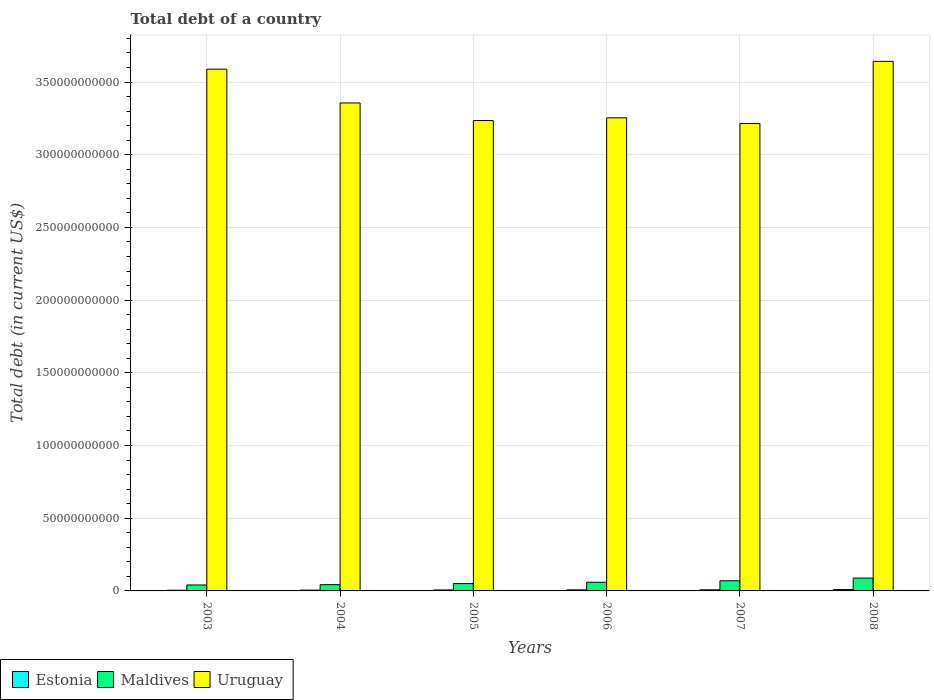Are the number of bars per tick equal to the number of legend labels?
Provide a succinct answer. Yes. What is the debt in Uruguay in 2003?
Give a very brief answer. 3.59e+11. Across all years, what is the maximum debt in Estonia?
Offer a very short reply. 9.20e+08. Across all years, what is the minimum debt in Uruguay?
Provide a short and direct response. 3.22e+11. In which year was the debt in Estonia maximum?
Your answer should be compact. 2008. What is the total debt in Uruguay in the graph?
Ensure brevity in your answer.  2.03e+12. What is the difference between the debt in Maldives in 2003 and that in 2004?
Offer a very short reply. -1.95e+08. What is the difference between the debt in Uruguay in 2003 and the debt in Maldives in 2004?
Ensure brevity in your answer.  3.55e+11. What is the average debt in Maldives per year?
Provide a succinct answer. 5.86e+09. In the year 2003, what is the difference between the debt in Uruguay and debt in Maldives?
Offer a very short reply. 3.55e+11. What is the ratio of the debt in Uruguay in 2004 to that in 2006?
Ensure brevity in your answer.  1.03. What is the difference between the highest and the second highest debt in Maldives?
Keep it short and to the point. 1.84e+09. What is the difference between the highest and the lowest debt in Uruguay?
Provide a short and direct response. 4.27e+1. In how many years, is the debt in Uruguay greater than the average debt in Uruguay taken over all years?
Make the answer very short. 2. What does the 1st bar from the left in 2008 represents?
Offer a terse response. Estonia. What does the 2nd bar from the right in 2003 represents?
Offer a very short reply. Maldives. Is it the case that in every year, the sum of the debt in Estonia and debt in Maldives is greater than the debt in Uruguay?
Ensure brevity in your answer.  No. How many bars are there?
Your answer should be compact. 18. How many years are there in the graph?
Provide a succinct answer. 6. Are the values on the major ticks of Y-axis written in scientific E-notation?
Ensure brevity in your answer.  No. Does the graph contain grids?
Provide a short and direct response. Yes. Where does the legend appear in the graph?
Your response must be concise. Bottom left. How many legend labels are there?
Your response must be concise. 3. How are the legend labels stacked?
Provide a succinct answer. Horizontal. What is the title of the graph?
Keep it short and to the point. Total debt of a country. What is the label or title of the X-axis?
Keep it short and to the point. Years. What is the label or title of the Y-axis?
Ensure brevity in your answer.  Total debt (in current US$). What is the Total debt (in current US$) in Estonia in 2003?
Make the answer very short. 4.56e+08. What is the Total debt (in current US$) in Maldives in 2003?
Keep it short and to the point. 4.09e+09. What is the Total debt (in current US$) in Uruguay in 2003?
Your answer should be compact. 3.59e+11. What is the Total debt (in current US$) in Estonia in 2004?
Give a very brief answer. 5.30e+08. What is the Total debt (in current US$) of Maldives in 2004?
Provide a succinct answer. 4.28e+09. What is the Total debt (in current US$) in Uruguay in 2004?
Provide a succinct answer. 3.36e+11. What is the Total debt (in current US$) in Estonia in 2005?
Your answer should be compact. 6.56e+08. What is the Total debt (in current US$) in Maldives in 2005?
Offer a terse response. 5.05e+09. What is the Total debt (in current US$) in Uruguay in 2005?
Keep it short and to the point. 3.24e+11. What is the Total debt (in current US$) in Estonia in 2006?
Your response must be concise. 7.41e+08. What is the Total debt (in current US$) in Maldives in 2006?
Give a very brief answer. 5.96e+09. What is the Total debt (in current US$) in Uruguay in 2006?
Your response must be concise. 3.25e+11. What is the Total debt (in current US$) in Estonia in 2007?
Provide a succinct answer. 7.73e+08. What is the Total debt (in current US$) of Maldives in 2007?
Your answer should be compact. 6.98e+09. What is the Total debt (in current US$) of Uruguay in 2007?
Your answer should be very brief. 3.22e+11. What is the Total debt (in current US$) in Estonia in 2008?
Offer a terse response. 9.20e+08. What is the Total debt (in current US$) of Maldives in 2008?
Keep it short and to the point. 8.82e+09. What is the Total debt (in current US$) in Uruguay in 2008?
Offer a terse response. 3.64e+11. Across all years, what is the maximum Total debt (in current US$) in Estonia?
Offer a very short reply. 9.20e+08. Across all years, what is the maximum Total debt (in current US$) in Maldives?
Provide a succinct answer. 8.82e+09. Across all years, what is the maximum Total debt (in current US$) of Uruguay?
Provide a succinct answer. 3.64e+11. Across all years, what is the minimum Total debt (in current US$) in Estonia?
Provide a short and direct response. 4.56e+08. Across all years, what is the minimum Total debt (in current US$) in Maldives?
Make the answer very short. 4.09e+09. Across all years, what is the minimum Total debt (in current US$) of Uruguay?
Offer a terse response. 3.22e+11. What is the total Total debt (in current US$) in Estonia in the graph?
Offer a terse response. 4.08e+09. What is the total Total debt (in current US$) of Maldives in the graph?
Offer a very short reply. 3.52e+1. What is the total Total debt (in current US$) in Uruguay in the graph?
Provide a succinct answer. 2.03e+12. What is the difference between the Total debt (in current US$) in Estonia in 2003 and that in 2004?
Offer a very short reply. -7.38e+07. What is the difference between the Total debt (in current US$) of Maldives in 2003 and that in 2004?
Your answer should be compact. -1.95e+08. What is the difference between the Total debt (in current US$) of Uruguay in 2003 and that in 2004?
Provide a succinct answer. 2.32e+1. What is the difference between the Total debt (in current US$) in Estonia in 2003 and that in 2005?
Offer a terse response. -1.99e+08. What is the difference between the Total debt (in current US$) in Maldives in 2003 and that in 2005?
Offer a very short reply. -9.64e+08. What is the difference between the Total debt (in current US$) in Uruguay in 2003 and that in 2005?
Provide a short and direct response. 3.53e+1. What is the difference between the Total debt (in current US$) in Estonia in 2003 and that in 2006?
Your answer should be very brief. -2.85e+08. What is the difference between the Total debt (in current US$) of Maldives in 2003 and that in 2006?
Make the answer very short. -1.87e+09. What is the difference between the Total debt (in current US$) of Uruguay in 2003 and that in 2006?
Give a very brief answer. 3.35e+1. What is the difference between the Total debt (in current US$) of Estonia in 2003 and that in 2007?
Make the answer very short. -3.17e+08. What is the difference between the Total debt (in current US$) in Maldives in 2003 and that in 2007?
Your answer should be very brief. -2.89e+09. What is the difference between the Total debt (in current US$) of Uruguay in 2003 and that in 2007?
Your answer should be compact. 3.73e+1. What is the difference between the Total debt (in current US$) of Estonia in 2003 and that in 2008?
Provide a succinct answer. -4.64e+08. What is the difference between the Total debt (in current US$) in Maldives in 2003 and that in 2008?
Make the answer very short. -4.74e+09. What is the difference between the Total debt (in current US$) in Uruguay in 2003 and that in 2008?
Give a very brief answer. -5.38e+09. What is the difference between the Total debt (in current US$) of Estonia in 2004 and that in 2005?
Keep it short and to the point. -1.26e+08. What is the difference between the Total debt (in current US$) of Maldives in 2004 and that in 2005?
Offer a very short reply. -7.69e+08. What is the difference between the Total debt (in current US$) of Uruguay in 2004 and that in 2005?
Your response must be concise. 1.21e+1. What is the difference between the Total debt (in current US$) in Estonia in 2004 and that in 2006?
Provide a succinct answer. -2.11e+08. What is the difference between the Total debt (in current US$) in Maldives in 2004 and that in 2006?
Your response must be concise. -1.67e+09. What is the difference between the Total debt (in current US$) of Uruguay in 2004 and that in 2006?
Your response must be concise. 1.02e+1. What is the difference between the Total debt (in current US$) in Estonia in 2004 and that in 2007?
Provide a succinct answer. -2.43e+08. What is the difference between the Total debt (in current US$) of Maldives in 2004 and that in 2007?
Provide a succinct answer. -2.70e+09. What is the difference between the Total debt (in current US$) of Uruguay in 2004 and that in 2007?
Keep it short and to the point. 1.41e+1. What is the difference between the Total debt (in current US$) in Estonia in 2004 and that in 2008?
Your response must be concise. -3.90e+08. What is the difference between the Total debt (in current US$) in Maldives in 2004 and that in 2008?
Provide a short and direct response. -4.54e+09. What is the difference between the Total debt (in current US$) in Uruguay in 2004 and that in 2008?
Make the answer very short. -2.86e+1. What is the difference between the Total debt (in current US$) in Estonia in 2005 and that in 2006?
Offer a terse response. -8.56e+07. What is the difference between the Total debt (in current US$) in Maldives in 2005 and that in 2006?
Make the answer very short. -9.04e+08. What is the difference between the Total debt (in current US$) of Uruguay in 2005 and that in 2006?
Provide a short and direct response. -1.85e+09. What is the difference between the Total debt (in current US$) of Estonia in 2005 and that in 2007?
Offer a terse response. -1.18e+08. What is the difference between the Total debt (in current US$) in Maldives in 2005 and that in 2007?
Keep it short and to the point. -1.93e+09. What is the difference between the Total debt (in current US$) in Uruguay in 2005 and that in 2007?
Provide a short and direct response. 1.99e+09. What is the difference between the Total debt (in current US$) of Estonia in 2005 and that in 2008?
Keep it short and to the point. -2.64e+08. What is the difference between the Total debt (in current US$) in Maldives in 2005 and that in 2008?
Your answer should be very brief. -3.77e+09. What is the difference between the Total debt (in current US$) of Uruguay in 2005 and that in 2008?
Offer a very short reply. -4.07e+1. What is the difference between the Total debt (in current US$) of Estonia in 2006 and that in 2007?
Keep it short and to the point. -3.21e+07. What is the difference between the Total debt (in current US$) in Maldives in 2006 and that in 2007?
Offer a terse response. -1.02e+09. What is the difference between the Total debt (in current US$) of Uruguay in 2006 and that in 2007?
Your response must be concise. 3.85e+09. What is the difference between the Total debt (in current US$) of Estonia in 2006 and that in 2008?
Provide a succinct answer. -1.79e+08. What is the difference between the Total debt (in current US$) of Maldives in 2006 and that in 2008?
Provide a succinct answer. -2.87e+09. What is the difference between the Total debt (in current US$) of Uruguay in 2006 and that in 2008?
Keep it short and to the point. -3.89e+1. What is the difference between the Total debt (in current US$) in Estonia in 2007 and that in 2008?
Offer a very short reply. -1.47e+08. What is the difference between the Total debt (in current US$) in Maldives in 2007 and that in 2008?
Ensure brevity in your answer.  -1.84e+09. What is the difference between the Total debt (in current US$) in Uruguay in 2007 and that in 2008?
Your answer should be very brief. -4.27e+1. What is the difference between the Total debt (in current US$) in Estonia in 2003 and the Total debt (in current US$) in Maldives in 2004?
Offer a terse response. -3.83e+09. What is the difference between the Total debt (in current US$) in Estonia in 2003 and the Total debt (in current US$) in Uruguay in 2004?
Keep it short and to the point. -3.35e+11. What is the difference between the Total debt (in current US$) in Maldives in 2003 and the Total debt (in current US$) in Uruguay in 2004?
Ensure brevity in your answer.  -3.32e+11. What is the difference between the Total debt (in current US$) in Estonia in 2003 and the Total debt (in current US$) in Maldives in 2005?
Your answer should be very brief. -4.60e+09. What is the difference between the Total debt (in current US$) in Estonia in 2003 and the Total debt (in current US$) in Uruguay in 2005?
Ensure brevity in your answer.  -3.23e+11. What is the difference between the Total debt (in current US$) of Maldives in 2003 and the Total debt (in current US$) of Uruguay in 2005?
Provide a succinct answer. -3.19e+11. What is the difference between the Total debt (in current US$) of Estonia in 2003 and the Total debt (in current US$) of Maldives in 2006?
Offer a very short reply. -5.50e+09. What is the difference between the Total debt (in current US$) in Estonia in 2003 and the Total debt (in current US$) in Uruguay in 2006?
Offer a terse response. -3.25e+11. What is the difference between the Total debt (in current US$) in Maldives in 2003 and the Total debt (in current US$) in Uruguay in 2006?
Provide a succinct answer. -3.21e+11. What is the difference between the Total debt (in current US$) in Estonia in 2003 and the Total debt (in current US$) in Maldives in 2007?
Ensure brevity in your answer.  -6.52e+09. What is the difference between the Total debt (in current US$) in Estonia in 2003 and the Total debt (in current US$) in Uruguay in 2007?
Make the answer very short. -3.21e+11. What is the difference between the Total debt (in current US$) of Maldives in 2003 and the Total debt (in current US$) of Uruguay in 2007?
Provide a succinct answer. -3.17e+11. What is the difference between the Total debt (in current US$) in Estonia in 2003 and the Total debt (in current US$) in Maldives in 2008?
Your answer should be very brief. -8.37e+09. What is the difference between the Total debt (in current US$) of Estonia in 2003 and the Total debt (in current US$) of Uruguay in 2008?
Offer a very short reply. -3.64e+11. What is the difference between the Total debt (in current US$) of Maldives in 2003 and the Total debt (in current US$) of Uruguay in 2008?
Offer a very short reply. -3.60e+11. What is the difference between the Total debt (in current US$) of Estonia in 2004 and the Total debt (in current US$) of Maldives in 2005?
Provide a succinct answer. -4.52e+09. What is the difference between the Total debt (in current US$) in Estonia in 2004 and the Total debt (in current US$) in Uruguay in 2005?
Your answer should be compact. -3.23e+11. What is the difference between the Total debt (in current US$) in Maldives in 2004 and the Total debt (in current US$) in Uruguay in 2005?
Keep it short and to the point. -3.19e+11. What is the difference between the Total debt (in current US$) in Estonia in 2004 and the Total debt (in current US$) in Maldives in 2006?
Your answer should be compact. -5.43e+09. What is the difference between the Total debt (in current US$) of Estonia in 2004 and the Total debt (in current US$) of Uruguay in 2006?
Offer a terse response. -3.25e+11. What is the difference between the Total debt (in current US$) of Maldives in 2004 and the Total debt (in current US$) of Uruguay in 2006?
Provide a short and direct response. -3.21e+11. What is the difference between the Total debt (in current US$) of Estonia in 2004 and the Total debt (in current US$) of Maldives in 2007?
Offer a terse response. -6.45e+09. What is the difference between the Total debt (in current US$) of Estonia in 2004 and the Total debt (in current US$) of Uruguay in 2007?
Your answer should be compact. -3.21e+11. What is the difference between the Total debt (in current US$) of Maldives in 2004 and the Total debt (in current US$) of Uruguay in 2007?
Give a very brief answer. -3.17e+11. What is the difference between the Total debt (in current US$) of Estonia in 2004 and the Total debt (in current US$) of Maldives in 2008?
Make the answer very short. -8.29e+09. What is the difference between the Total debt (in current US$) of Estonia in 2004 and the Total debt (in current US$) of Uruguay in 2008?
Your answer should be very brief. -3.64e+11. What is the difference between the Total debt (in current US$) of Maldives in 2004 and the Total debt (in current US$) of Uruguay in 2008?
Provide a short and direct response. -3.60e+11. What is the difference between the Total debt (in current US$) in Estonia in 2005 and the Total debt (in current US$) in Maldives in 2006?
Give a very brief answer. -5.30e+09. What is the difference between the Total debt (in current US$) in Estonia in 2005 and the Total debt (in current US$) in Uruguay in 2006?
Make the answer very short. -3.25e+11. What is the difference between the Total debt (in current US$) in Maldives in 2005 and the Total debt (in current US$) in Uruguay in 2006?
Offer a very short reply. -3.20e+11. What is the difference between the Total debt (in current US$) of Estonia in 2005 and the Total debt (in current US$) of Maldives in 2007?
Your response must be concise. -6.32e+09. What is the difference between the Total debt (in current US$) of Estonia in 2005 and the Total debt (in current US$) of Uruguay in 2007?
Offer a terse response. -3.21e+11. What is the difference between the Total debt (in current US$) of Maldives in 2005 and the Total debt (in current US$) of Uruguay in 2007?
Your answer should be compact. -3.16e+11. What is the difference between the Total debt (in current US$) of Estonia in 2005 and the Total debt (in current US$) of Maldives in 2008?
Make the answer very short. -8.17e+09. What is the difference between the Total debt (in current US$) in Estonia in 2005 and the Total debt (in current US$) in Uruguay in 2008?
Give a very brief answer. -3.64e+11. What is the difference between the Total debt (in current US$) of Maldives in 2005 and the Total debt (in current US$) of Uruguay in 2008?
Offer a very short reply. -3.59e+11. What is the difference between the Total debt (in current US$) of Estonia in 2006 and the Total debt (in current US$) of Maldives in 2007?
Make the answer very short. -6.24e+09. What is the difference between the Total debt (in current US$) of Estonia in 2006 and the Total debt (in current US$) of Uruguay in 2007?
Give a very brief answer. -3.21e+11. What is the difference between the Total debt (in current US$) in Maldives in 2006 and the Total debt (in current US$) in Uruguay in 2007?
Make the answer very short. -3.16e+11. What is the difference between the Total debt (in current US$) of Estonia in 2006 and the Total debt (in current US$) of Maldives in 2008?
Offer a very short reply. -8.08e+09. What is the difference between the Total debt (in current US$) in Estonia in 2006 and the Total debt (in current US$) in Uruguay in 2008?
Offer a very short reply. -3.63e+11. What is the difference between the Total debt (in current US$) in Maldives in 2006 and the Total debt (in current US$) in Uruguay in 2008?
Make the answer very short. -3.58e+11. What is the difference between the Total debt (in current US$) in Estonia in 2007 and the Total debt (in current US$) in Maldives in 2008?
Make the answer very short. -8.05e+09. What is the difference between the Total debt (in current US$) in Estonia in 2007 and the Total debt (in current US$) in Uruguay in 2008?
Your answer should be compact. -3.63e+11. What is the difference between the Total debt (in current US$) of Maldives in 2007 and the Total debt (in current US$) of Uruguay in 2008?
Your answer should be very brief. -3.57e+11. What is the average Total debt (in current US$) of Estonia per year?
Your response must be concise. 6.79e+08. What is the average Total debt (in current US$) in Maldives per year?
Provide a succinct answer. 5.86e+09. What is the average Total debt (in current US$) of Uruguay per year?
Provide a succinct answer. 3.38e+11. In the year 2003, what is the difference between the Total debt (in current US$) of Estonia and Total debt (in current US$) of Maldives?
Your answer should be compact. -3.63e+09. In the year 2003, what is the difference between the Total debt (in current US$) in Estonia and Total debt (in current US$) in Uruguay?
Make the answer very short. -3.58e+11. In the year 2003, what is the difference between the Total debt (in current US$) in Maldives and Total debt (in current US$) in Uruguay?
Your response must be concise. -3.55e+11. In the year 2004, what is the difference between the Total debt (in current US$) in Estonia and Total debt (in current US$) in Maldives?
Make the answer very short. -3.75e+09. In the year 2004, what is the difference between the Total debt (in current US$) of Estonia and Total debt (in current US$) of Uruguay?
Your response must be concise. -3.35e+11. In the year 2004, what is the difference between the Total debt (in current US$) of Maldives and Total debt (in current US$) of Uruguay?
Offer a terse response. -3.31e+11. In the year 2005, what is the difference between the Total debt (in current US$) in Estonia and Total debt (in current US$) in Maldives?
Provide a succinct answer. -4.40e+09. In the year 2005, what is the difference between the Total debt (in current US$) of Estonia and Total debt (in current US$) of Uruguay?
Keep it short and to the point. -3.23e+11. In the year 2005, what is the difference between the Total debt (in current US$) in Maldives and Total debt (in current US$) in Uruguay?
Your answer should be compact. -3.18e+11. In the year 2006, what is the difference between the Total debt (in current US$) of Estonia and Total debt (in current US$) of Maldives?
Your response must be concise. -5.21e+09. In the year 2006, what is the difference between the Total debt (in current US$) in Estonia and Total debt (in current US$) in Uruguay?
Provide a short and direct response. -3.25e+11. In the year 2006, what is the difference between the Total debt (in current US$) in Maldives and Total debt (in current US$) in Uruguay?
Provide a short and direct response. -3.19e+11. In the year 2007, what is the difference between the Total debt (in current US$) in Estonia and Total debt (in current US$) in Maldives?
Offer a very short reply. -6.21e+09. In the year 2007, what is the difference between the Total debt (in current US$) of Estonia and Total debt (in current US$) of Uruguay?
Your answer should be very brief. -3.21e+11. In the year 2007, what is the difference between the Total debt (in current US$) of Maldives and Total debt (in current US$) of Uruguay?
Provide a short and direct response. -3.15e+11. In the year 2008, what is the difference between the Total debt (in current US$) in Estonia and Total debt (in current US$) in Maldives?
Provide a short and direct response. -7.90e+09. In the year 2008, what is the difference between the Total debt (in current US$) of Estonia and Total debt (in current US$) of Uruguay?
Provide a short and direct response. -3.63e+11. In the year 2008, what is the difference between the Total debt (in current US$) in Maldives and Total debt (in current US$) in Uruguay?
Provide a succinct answer. -3.55e+11. What is the ratio of the Total debt (in current US$) in Estonia in 2003 to that in 2004?
Your response must be concise. 0.86. What is the ratio of the Total debt (in current US$) of Maldives in 2003 to that in 2004?
Provide a short and direct response. 0.95. What is the ratio of the Total debt (in current US$) of Uruguay in 2003 to that in 2004?
Give a very brief answer. 1.07. What is the ratio of the Total debt (in current US$) of Estonia in 2003 to that in 2005?
Make the answer very short. 0.7. What is the ratio of the Total debt (in current US$) in Maldives in 2003 to that in 2005?
Ensure brevity in your answer.  0.81. What is the ratio of the Total debt (in current US$) of Uruguay in 2003 to that in 2005?
Keep it short and to the point. 1.11. What is the ratio of the Total debt (in current US$) of Estonia in 2003 to that in 2006?
Offer a terse response. 0.62. What is the ratio of the Total debt (in current US$) of Maldives in 2003 to that in 2006?
Your response must be concise. 0.69. What is the ratio of the Total debt (in current US$) in Uruguay in 2003 to that in 2006?
Give a very brief answer. 1.1. What is the ratio of the Total debt (in current US$) of Estonia in 2003 to that in 2007?
Make the answer very short. 0.59. What is the ratio of the Total debt (in current US$) of Maldives in 2003 to that in 2007?
Offer a terse response. 0.59. What is the ratio of the Total debt (in current US$) of Uruguay in 2003 to that in 2007?
Offer a terse response. 1.12. What is the ratio of the Total debt (in current US$) in Estonia in 2003 to that in 2008?
Keep it short and to the point. 0.5. What is the ratio of the Total debt (in current US$) of Maldives in 2003 to that in 2008?
Make the answer very short. 0.46. What is the ratio of the Total debt (in current US$) of Uruguay in 2003 to that in 2008?
Provide a short and direct response. 0.99. What is the ratio of the Total debt (in current US$) of Estonia in 2004 to that in 2005?
Keep it short and to the point. 0.81. What is the ratio of the Total debt (in current US$) of Maldives in 2004 to that in 2005?
Your response must be concise. 0.85. What is the ratio of the Total debt (in current US$) of Uruguay in 2004 to that in 2005?
Give a very brief answer. 1.04. What is the ratio of the Total debt (in current US$) of Estonia in 2004 to that in 2006?
Your response must be concise. 0.72. What is the ratio of the Total debt (in current US$) in Maldives in 2004 to that in 2006?
Make the answer very short. 0.72. What is the ratio of the Total debt (in current US$) of Uruguay in 2004 to that in 2006?
Keep it short and to the point. 1.03. What is the ratio of the Total debt (in current US$) in Estonia in 2004 to that in 2007?
Your response must be concise. 0.69. What is the ratio of the Total debt (in current US$) in Maldives in 2004 to that in 2007?
Ensure brevity in your answer.  0.61. What is the ratio of the Total debt (in current US$) of Uruguay in 2004 to that in 2007?
Keep it short and to the point. 1.04. What is the ratio of the Total debt (in current US$) in Estonia in 2004 to that in 2008?
Your response must be concise. 0.58. What is the ratio of the Total debt (in current US$) of Maldives in 2004 to that in 2008?
Offer a terse response. 0.49. What is the ratio of the Total debt (in current US$) of Uruguay in 2004 to that in 2008?
Your answer should be very brief. 0.92. What is the ratio of the Total debt (in current US$) of Estonia in 2005 to that in 2006?
Give a very brief answer. 0.88. What is the ratio of the Total debt (in current US$) of Maldives in 2005 to that in 2006?
Your answer should be compact. 0.85. What is the ratio of the Total debt (in current US$) in Uruguay in 2005 to that in 2006?
Provide a short and direct response. 0.99. What is the ratio of the Total debt (in current US$) of Estonia in 2005 to that in 2007?
Your response must be concise. 0.85. What is the ratio of the Total debt (in current US$) in Maldives in 2005 to that in 2007?
Provide a succinct answer. 0.72. What is the ratio of the Total debt (in current US$) of Uruguay in 2005 to that in 2007?
Offer a very short reply. 1.01. What is the ratio of the Total debt (in current US$) of Estonia in 2005 to that in 2008?
Your response must be concise. 0.71. What is the ratio of the Total debt (in current US$) in Maldives in 2005 to that in 2008?
Give a very brief answer. 0.57. What is the ratio of the Total debt (in current US$) of Uruguay in 2005 to that in 2008?
Offer a terse response. 0.89. What is the ratio of the Total debt (in current US$) in Estonia in 2006 to that in 2007?
Keep it short and to the point. 0.96. What is the ratio of the Total debt (in current US$) in Maldives in 2006 to that in 2007?
Your answer should be very brief. 0.85. What is the ratio of the Total debt (in current US$) of Estonia in 2006 to that in 2008?
Make the answer very short. 0.81. What is the ratio of the Total debt (in current US$) in Maldives in 2006 to that in 2008?
Your response must be concise. 0.68. What is the ratio of the Total debt (in current US$) in Uruguay in 2006 to that in 2008?
Your answer should be very brief. 0.89. What is the ratio of the Total debt (in current US$) of Estonia in 2007 to that in 2008?
Make the answer very short. 0.84. What is the ratio of the Total debt (in current US$) of Maldives in 2007 to that in 2008?
Keep it short and to the point. 0.79. What is the ratio of the Total debt (in current US$) of Uruguay in 2007 to that in 2008?
Offer a very short reply. 0.88. What is the difference between the highest and the second highest Total debt (in current US$) in Estonia?
Give a very brief answer. 1.47e+08. What is the difference between the highest and the second highest Total debt (in current US$) of Maldives?
Provide a succinct answer. 1.84e+09. What is the difference between the highest and the second highest Total debt (in current US$) of Uruguay?
Offer a terse response. 5.38e+09. What is the difference between the highest and the lowest Total debt (in current US$) of Estonia?
Offer a very short reply. 4.64e+08. What is the difference between the highest and the lowest Total debt (in current US$) in Maldives?
Offer a very short reply. 4.74e+09. What is the difference between the highest and the lowest Total debt (in current US$) of Uruguay?
Provide a succinct answer. 4.27e+1. 